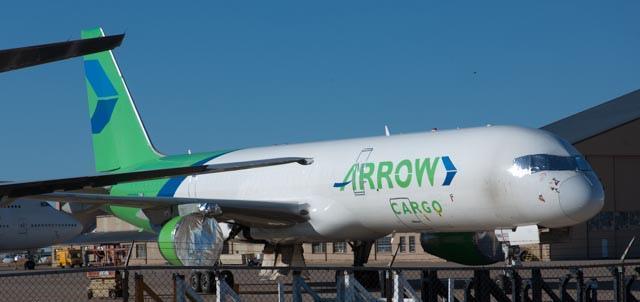How many planes are there?
Give a very brief answer. 2. How many airplanes are there?
Give a very brief answer. 2. 